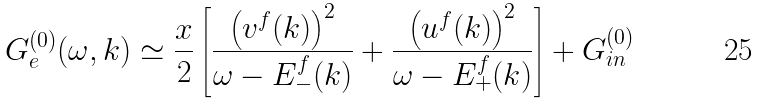Convert formula to latex. <formula><loc_0><loc_0><loc_500><loc_500>G _ { e } ^ { ( 0 ) } ( \omega , k ) \simeq \frac { x } { 2 } \left [ \frac { \left ( v ^ { f } ( k ) \right ) ^ { 2 } } { \omega - E _ { - } ^ { f } ( k ) } + \frac { \left ( u ^ { f } ( k ) \right ) ^ { 2 } } { \omega - E _ { + } ^ { f } ( k ) } \right ] + G _ { i n } ^ { ( 0 ) }</formula> 